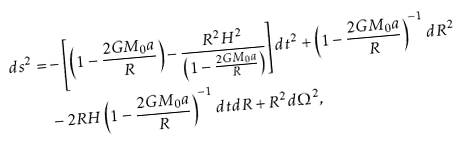<formula> <loc_0><loc_0><loc_500><loc_500>d s ^ { 2 } = & - \left [ \left ( 1 - \frac { 2 G M _ { 0 } a } { R } \right ) - \frac { R ^ { 2 } H ^ { 2 } } { \left ( 1 - \frac { 2 G M _ { 0 } a } { R } \right ) } \right ] d t ^ { 2 } + \left ( 1 - \frac { 2 G M _ { 0 } a } { R } \right ) ^ { - 1 } d R ^ { 2 } \\ & - 2 R H \left ( 1 - \frac { 2 G M _ { 0 } a } { R } \right ) ^ { - 1 } d t d R + R ^ { 2 } d \Omega ^ { 2 } ,</formula> 